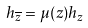<formula> <loc_0><loc_0><loc_500><loc_500>h _ { \overline { z } } = \mu ( z ) h _ { z }</formula> 